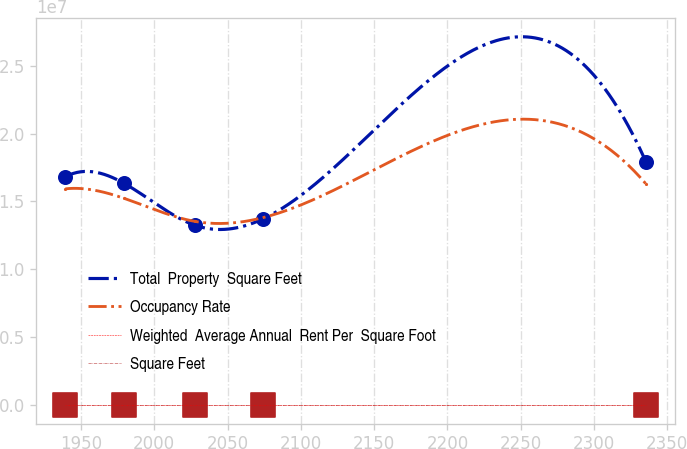Convert chart. <chart><loc_0><loc_0><loc_500><loc_500><line_chart><ecel><fcel>Total  Property  Square Feet<fcel>Occupancy Rate<fcel>Weighted  Average Annual  Rent Per  Square Foot<fcel>Square Feet<nl><fcel>1939.38<fcel>1.68249e+07<fcel>1.59282e+07<fcel>78.29<fcel>44.39<nl><fcel>1978.98<fcel>1.63551e+07<fcel>1.52415e+07<fcel>89.41<fcel>43.84<nl><fcel>2027.81<fcel>1.32416e+07<fcel>1.35283e+07<fcel>83.99<fcel>39.76<nl><fcel>2074.1<fcel>1.37114e+07<fcel>1.38057e+07<fcel>73.39<fcel>39.21<nl><fcel>2335.4<fcel>1.79398e+07<fcel>1.63028e+07<fcel>98.96<fcel>38.62<nl></chart> 